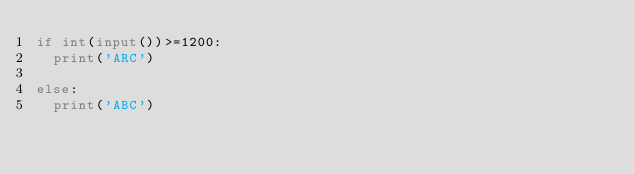<code> <loc_0><loc_0><loc_500><loc_500><_Python_>if int(input())>=1200:
  print('ARC')
  
else:
  print('ABC')</code> 